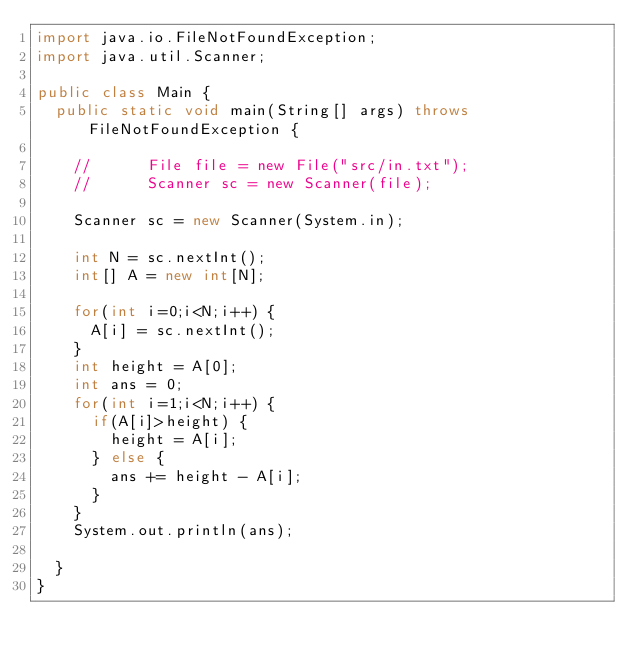<code> <loc_0><loc_0><loc_500><loc_500><_Java_>import java.io.FileNotFoundException;
import java.util.Scanner;

public class Main {
	public static void main(String[] args) throws FileNotFoundException {

		//    	File file = new File("src/in.txt");
		//    	Scanner sc = new Scanner(file);

		Scanner sc = new Scanner(System.in);

		int N = sc.nextInt();
		int[] A = new int[N];

		for(int i=0;i<N;i++) {
			A[i] = sc.nextInt();
		}
		int height = A[0];
		int ans = 0;
		for(int i=1;i<N;i++) {
			if(A[i]>height) {
				height = A[i];
			} else {
				ans += height - A[i];
			}
		}
		System.out.println(ans);

	}
}
</code> 